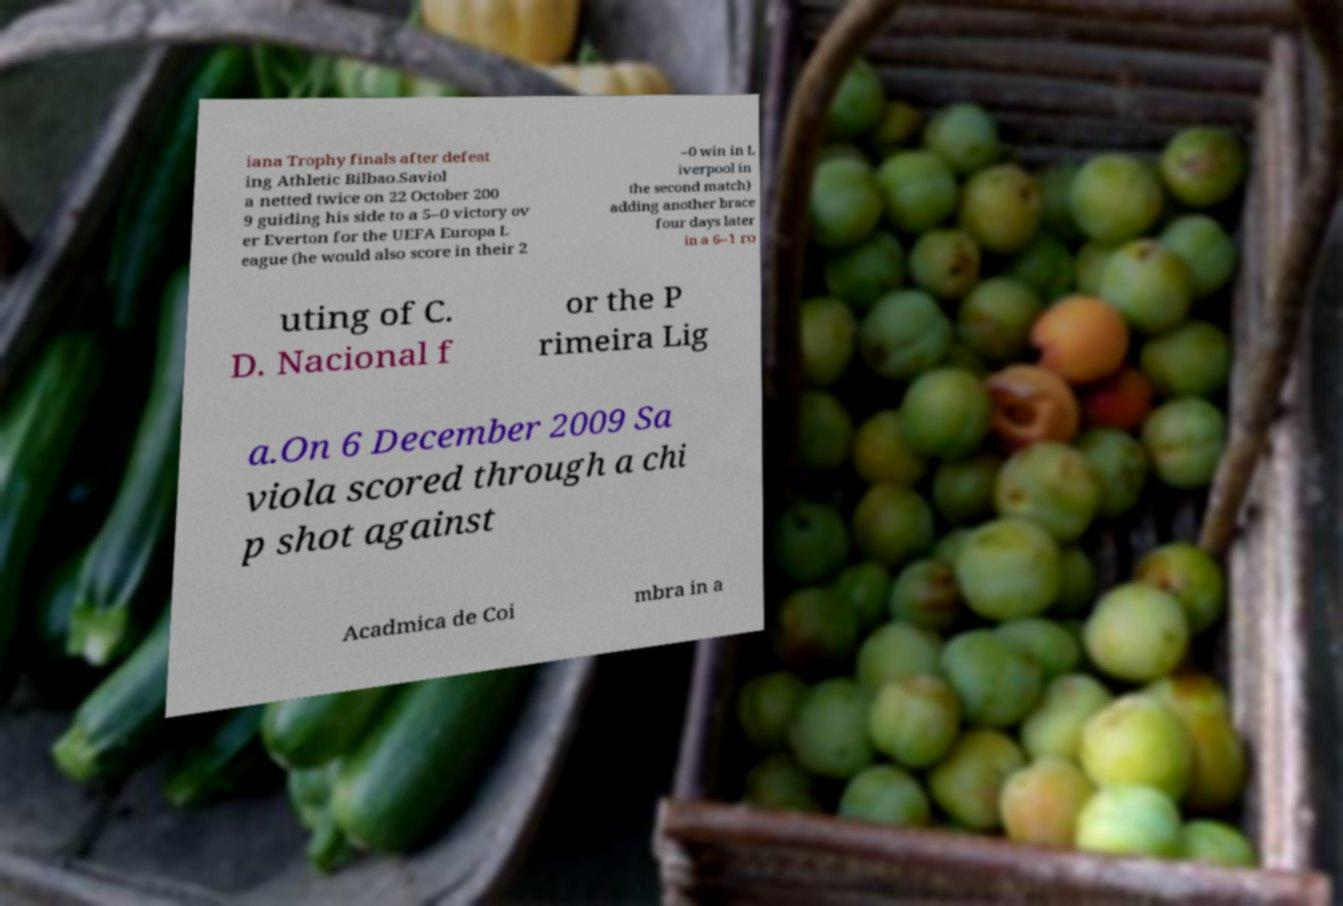Can you accurately transcribe the text from the provided image for me? iana Trophy finals after defeat ing Athletic Bilbao.Saviol a netted twice on 22 October 200 9 guiding his side to a 5–0 victory ov er Everton for the UEFA Europa L eague (he would also score in their 2 –0 win in L iverpool in the second match) adding another brace four days later in a 6–1 ro uting of C. D. Nacional f or the P rimeira Lig a.On 6 December 2009 Sa viola scored through a chi p shot against Acadmica de Coi mbra in a 